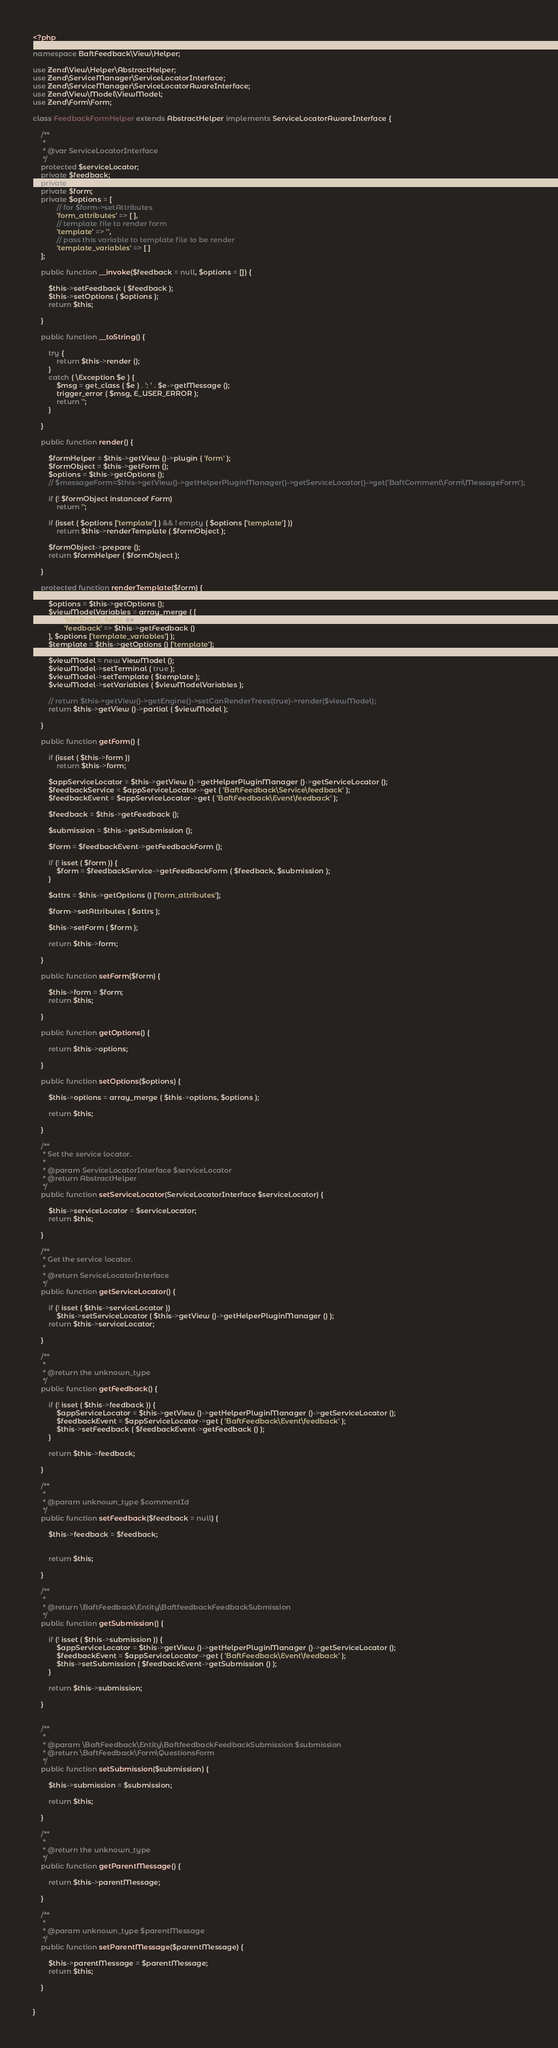Convert code to text. <code><loc_0><loc_0><loc_500><loc_500><_PHP_><?php

namespace BaftFeedback\View\Helper;

use Zend\View\Helper\AbstractHelper;
use Zend\ServiceManager\ServiceLocatorInterface;
use Zend\ServiceManager\ServiceLocatorAwareInterface;
use Zend\View\Model\ViewModel;
use Zend\Form\Form;

class FeedbackFormHelper extends AbstractHelper implements ServiceLocatorAwareInterface {
	
	/**
	 *
	 * @var ServiceLocatorInterface
	 */
	protected $serviceLocator;
	private $feedback;
	private $submission;
	private $form;
	private $options = [
			// for $form->setAttributes
			'form_attributes' => [ ],
			// template file to render form
			'template' => '',
			// pass this variable to template file to be render
			'template_variables' => [ ] 
	];

	public function __invoke($feedback = null, $options = []) {

		$this->setFeedback ( $feedback );
		$this->setOptions ( $options );
		return $this;
	
	}

	public function __toString() {

		try {
			return $this->render ();
		}
		catch ( \Exception $e ) {
			$msg = get_class ( $e ) . ': ' . $e->getMessage ();
			trigger_error ( $msg, E_USER_ERROR );
			return '';
		}
	
	}

	public function render() {

		$formHelper = $this->getView ()->plugin ( 'form' );
		$formObject = $this->getForm ();
		$options = $this->getOptions ();
		// $messageForm=$this->getView()->getHelperPluginManager()->getServiceLocator()->get('BaftComment\Form\MessageForm');
		
		if (! $formObject instanceof Form)
			return '';
		
		if (isset ( $options ['template'] ) && ! empty ( $options ['template'] ))
			return $this->renderTemplate ( $formObject );
		
		$formObject->prepare ();
		return $formHelper ( $formObject );
	
	}

	protected function renderTemplate($form) {

		$options = $this->getOptions ();
		$viewModelVariables = array_merge ( [ 
				'feedback_form' => $form,
				'feedback' => $this->getFeedback () 
		], $options ['template_variables'] );
		$template = $this->getOptions () ['template'];
		
		$viewModel = new ViewModel ();
		$viewModel->setTerminal ( true );
		$viewModel->setTemplate ( $template );
		$viewModel->setVariables ( $viewModelVariables );
		
		// return $this->getView()->getEngine()->setCanRenderTrees(true)->render($viewModel);
		return $this->getView ()->partial ( $viewModel );
	
	}

	public function getForm() {

		if (isset ( $this->form ))
			return $this->form;
		
		$appServiceLocator = $this->getView ()->getHelperPluginManager ()->getServiceLocator ();
		$feedbackService = $appServiceLocator->get ( 'BaftFeedback\Service\feedback' );
		$feedbackEvent = $appServiceLocator->get ( 'BaftFeedback\Event\feedback' );
		
		$feedback = $this->getFeedback ();
		
		$submission = $this->getSubmission ();
		
		$form = $feedbackEvent->getFeedbackForm ();
		
		if (! isset ( $form )) {
			$form = $feedbackService->getFeedbackForm ( $feedback, $submission );
		}
		
		$attrs = $this->getOptions () ['form_attributes'];
		
		$form->setAttributes ( $attrs );
		
		$this->setForm ( $form );
		
		return $this->form;
	
	}

	public function setForm($form) {

		$this->form = $form;
		return $this;
	
	}

	public function getOptions() {

		return $this->options;
	
	}

	public function setOptions($options) {

		$this->options = array_merge ( $this->options, $options );
		
		return $this;
	
	}

	/**
	 * Set the service locator.
	 *
	 * @param ServiceLocatorInterface $serviceLocator        	
	 * @return AbstractHelper
	 */
	public function setServiceLocator(ServiceLocatorInterface $serviceLocator) {

		$this->serviceLocator = $serviceLocator;
		return $this;
	
	}

	/**
	 * Get the service locator.
	 *
	 * @return ServiceLocatorInterface
	 */
	public function getServiceLocator() {

		if (! isset ( $this->serviceLocator ))
			$this->setServiceLocator ( $this->getView ()->getHelperPluginManager () );
		return $this->serviceLocator;
	
	}

	/**
	 *
	 * @return the unknown_type
	 */
	public function getFeedback() {

		if (! isset ( $this->feedback )) {
			$appServiceLocator = $this->getView ()->getHelperPluginManager ()->getServiceLocator ();
			$feedbackEvent = $appServiceLocator->get ( 'BaftFeedback\Event\feedback' );
			$this->setFeedback ( $feedbackEvent->getFeedback () );
		}
		
		return $this->feedback;
	
	}

	/**
	 *
	 * @param unknown_type $commentId        	
	 */
	public function setFeedback($feedback = null) {

		$this->feedback = $feedback;
		

		return $this;
	
	}

	/**
	 *
	 * @return \BaftFeedback\Entity\BaftfeedbackFeedbackSubmission
	 */
	public function getSubmission() {

		if (! isset ( $this->submission )) {
			$appServiceLocator = $this->getView ()->getHelperPluginManager ()->getServiceLocator ();
			$feedbackEvent = $appServiceLocator->get ( 'BaftFeedback\Event\feedback' );
			$this->setSubmission ( $feedbackEvent->getSubmission () );
		}
		
		return $this->submission;
	
	}

	
	/**
	 *
	 * @param \BaftFeedback\Entity\BaftfeedbackFeedbackSubmission $submission        	
	 * @return \BaftFeedback\Form\QuestionsForm
	 */
	public function setSubmission($submission) {

		$this->submission = $submission;
		
		return $this;
	
	}

	/**
	 *
	 * @return the unknown_type
	 */
	public function getParentMessage() {

		return $this->parentMessage;
	
	}

	/**
	 *
	 * @param unknown_type $parentMessage        	
	 */
	public function setParentMessage($parentMessage) {

		$this->parentMessage = $parentMessage;
		return $this;
	
	}


}</code> 